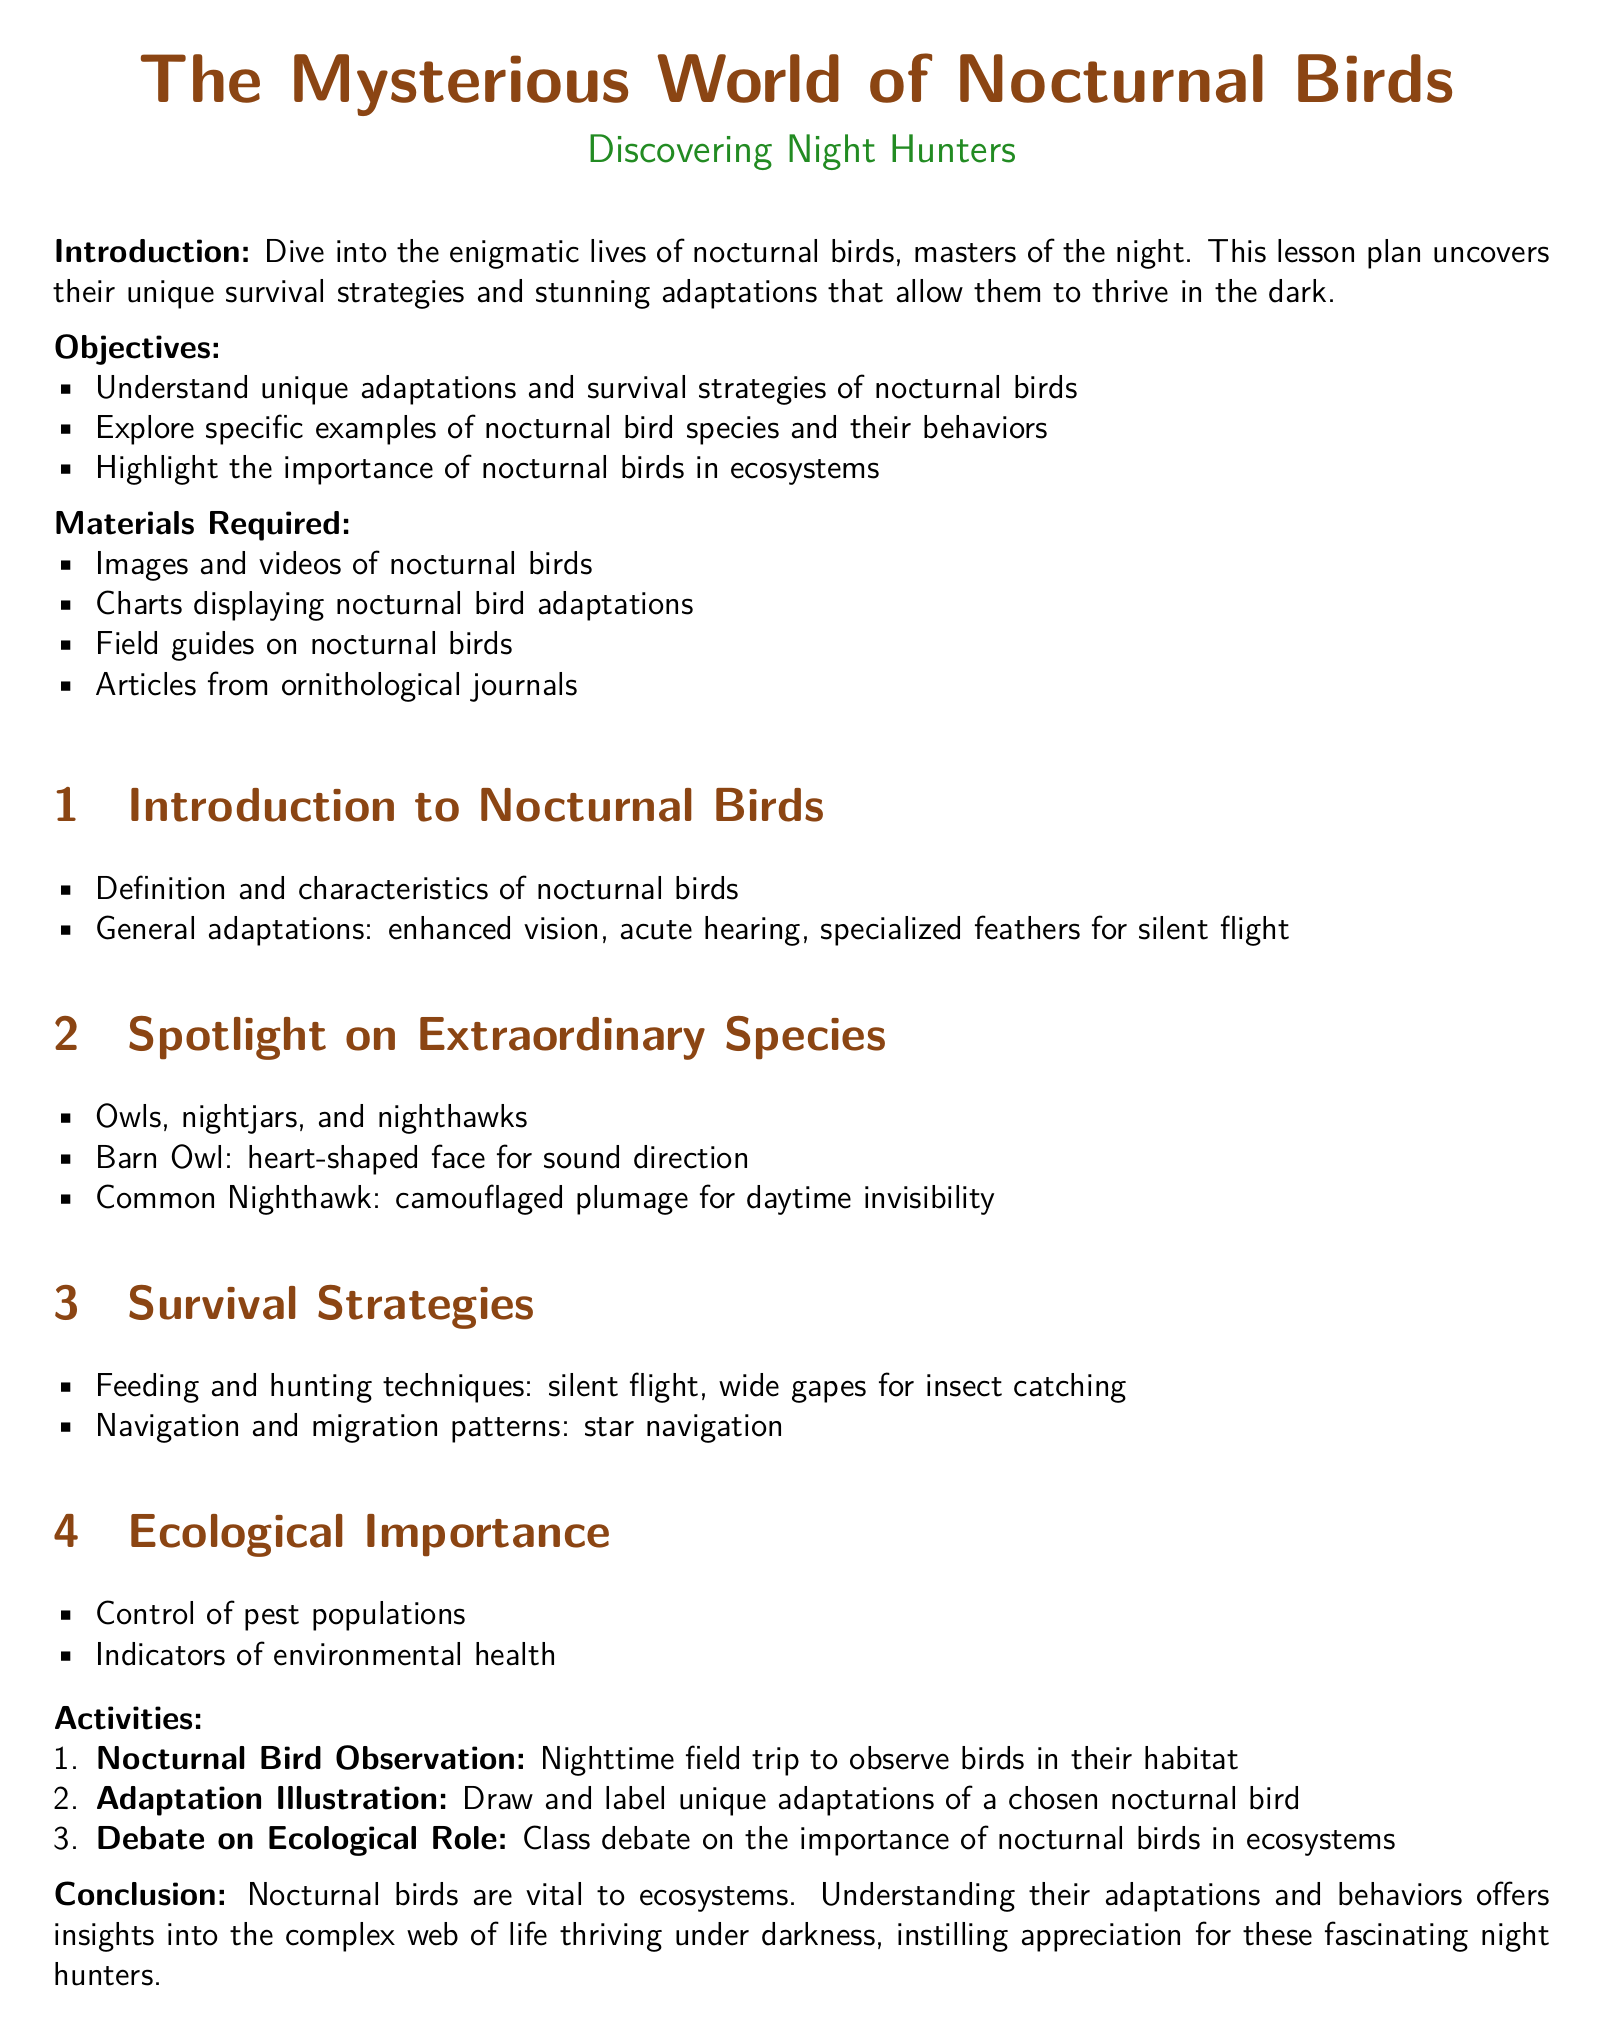what is the title of the lesson plan? The title of the lesson plan is specifically mentioned at the beginning of the document.
Answer: The Mysterious World of Nocturnal Birds what is one example of a nocturnal bird species mentioned? The document provides specific examples of species in the section dedicated to extraordinary species.
Answer: Barn Owl what is a key adaptation of nocturnal birds? The document lists adaptations in the introduction with specific details about their abilities.
Answer: Enhanced vision how do nocturnal birds help the ecosystem? The ecological importance section highlights their role in the environment, particularly in pest control.
Answer: Control of pest populations how many objectives are outlined in the lesson plan? A count of the bullet points under the objectives section provides this information.
Answer: Three what type of activity involves drawing and labeling? The activities section describes various tasks, one of which involves artistic skills.
Answer: Adaptation Illustration which bird has a heart-shaped face? In the spotlight section, specific features of certain birds are highlighted, including this identifying trait.
Answer: Barn Owl what is one method nocturnal birds use for hunting? The survival strategies section lists techniques utilized by these birds when hunting at night.
Answer: Silent flight how many materials are required for this lesson plan? The number of items in the materials required section directly answers this.
Answer: Four 